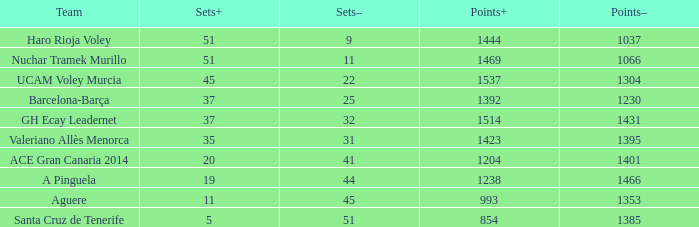What is the highest Points+ number when the Points- number is larger than 1385, a Sets+ number smaller than 37 and a Sets- number larger than 41? 1238.0. 